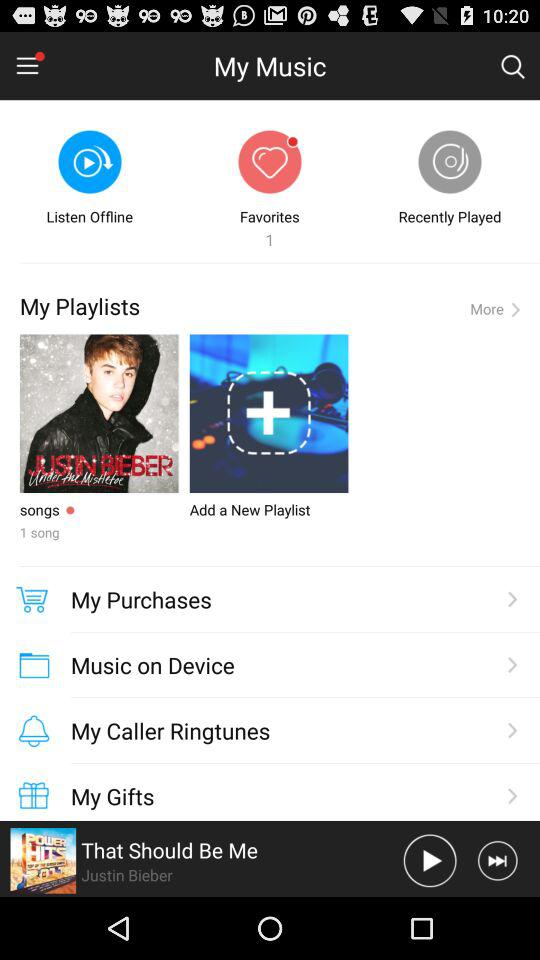What song is playing? The song is "That Should Be Me". 